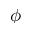<formula> <loc_0><loc_0><loc_500><loc_500>\phi</formula> 